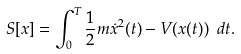<formula> <loc_0><loc_0><loc_500><loc_500>S [ x ] = \int _ { 0 } ^ { T } \frac { 1 } { 2 } m \dot { x } ^ { 2 } ( t ) - V ( x ( t ) ) \ d t .</formula> 